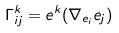Convert formula to latex. <formula><loc_0><loc_0><loc_500><loc_500>\Gamma _ { i j } ^ { k } = e ^ { k } ( \nabla _ { e _ { i } } e _ { j } )</formula> 